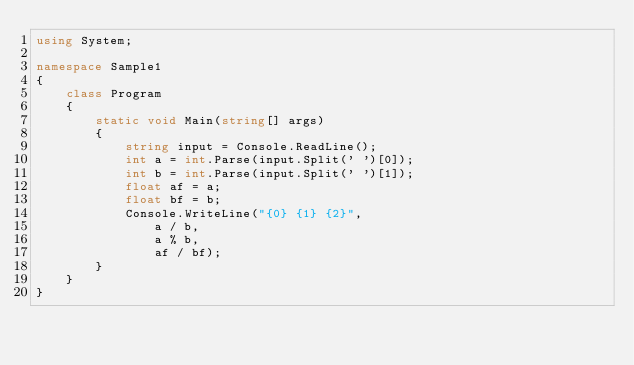Convert code to text. <code><loc_0><loc_0><loc_500><loc_500><_C#_>using System;

namespace Sample1
{
    class Program
    {
        static void Main(string[] args)
        {
            string input = Console.ReadLine();
            int a = int.Parse(input.Split(' ')[0]);
            int b = int.Parse(input.Split(' ')[1]);
            float af = a;
            float bf = b;
            Console.WriteLine("{0} {1} {2}",
                a / b,
                a % b,
                af / bf);
        }
    }
}</code> 